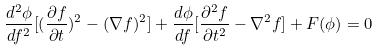<formula> <loc_0><loc_0><loc_500><loc_500>\frac { d ^ { 2 } \phi } { d f ^ { 2 } } [ ( \frac { \partial f } { \partial t } ) ^ { 2 } - ( \nabla f ) ^ { 2 } ] + \frac { d \phi } { d f } [ \frac { \partial ^ { 2 } f } { \partial t ^ { 2 } } - \nabla ^ { 2 } f ] + F ( \phi ) = 0</formula> 